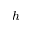<formula> <loc_0><loc_0><loc_500><loc_500>h</formula> 